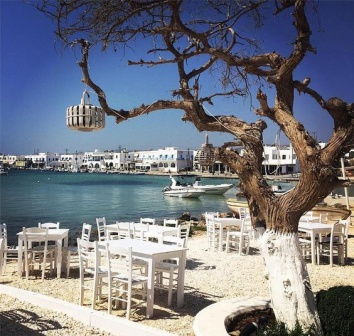What kind of meals do you think are served at this seaside restaurant? Given the seaside setting, it is likely that the restaurant serves a variety of seafood dishes, such as grilled fish, calamari, shrimp cocktail, and mussels. The menu might also include Mediterranean cuisine like fresh salads, bruschetta, and pasta dishes. For drinks, the restaurant probably offers a selection of wines, refreshing cocktails, and perhaps even some local specialties that complement the coastal dining experience. Describe the ambiance during a busy evening at this restaurant. During a busy evening, the seaside restaurant comes alive with the soft murmur of conversations and the clinking of cutlery against plates. The tables are filled with guests enjoying their meals under the warm glow of ambient lighting, perhaps provided by candles or string lights. The scent of fresh seafood and Mediterranean spices wafts through the air, blending with the salty sea breeze. The harbor in the background is illuminated by the lights from the boats and the reflections of the moon on the water, creating a magical backdrop. Live music, maybe a local guitarist, adds to the enchanting atmosphere, making it a delightful and memorable evening for all present. 